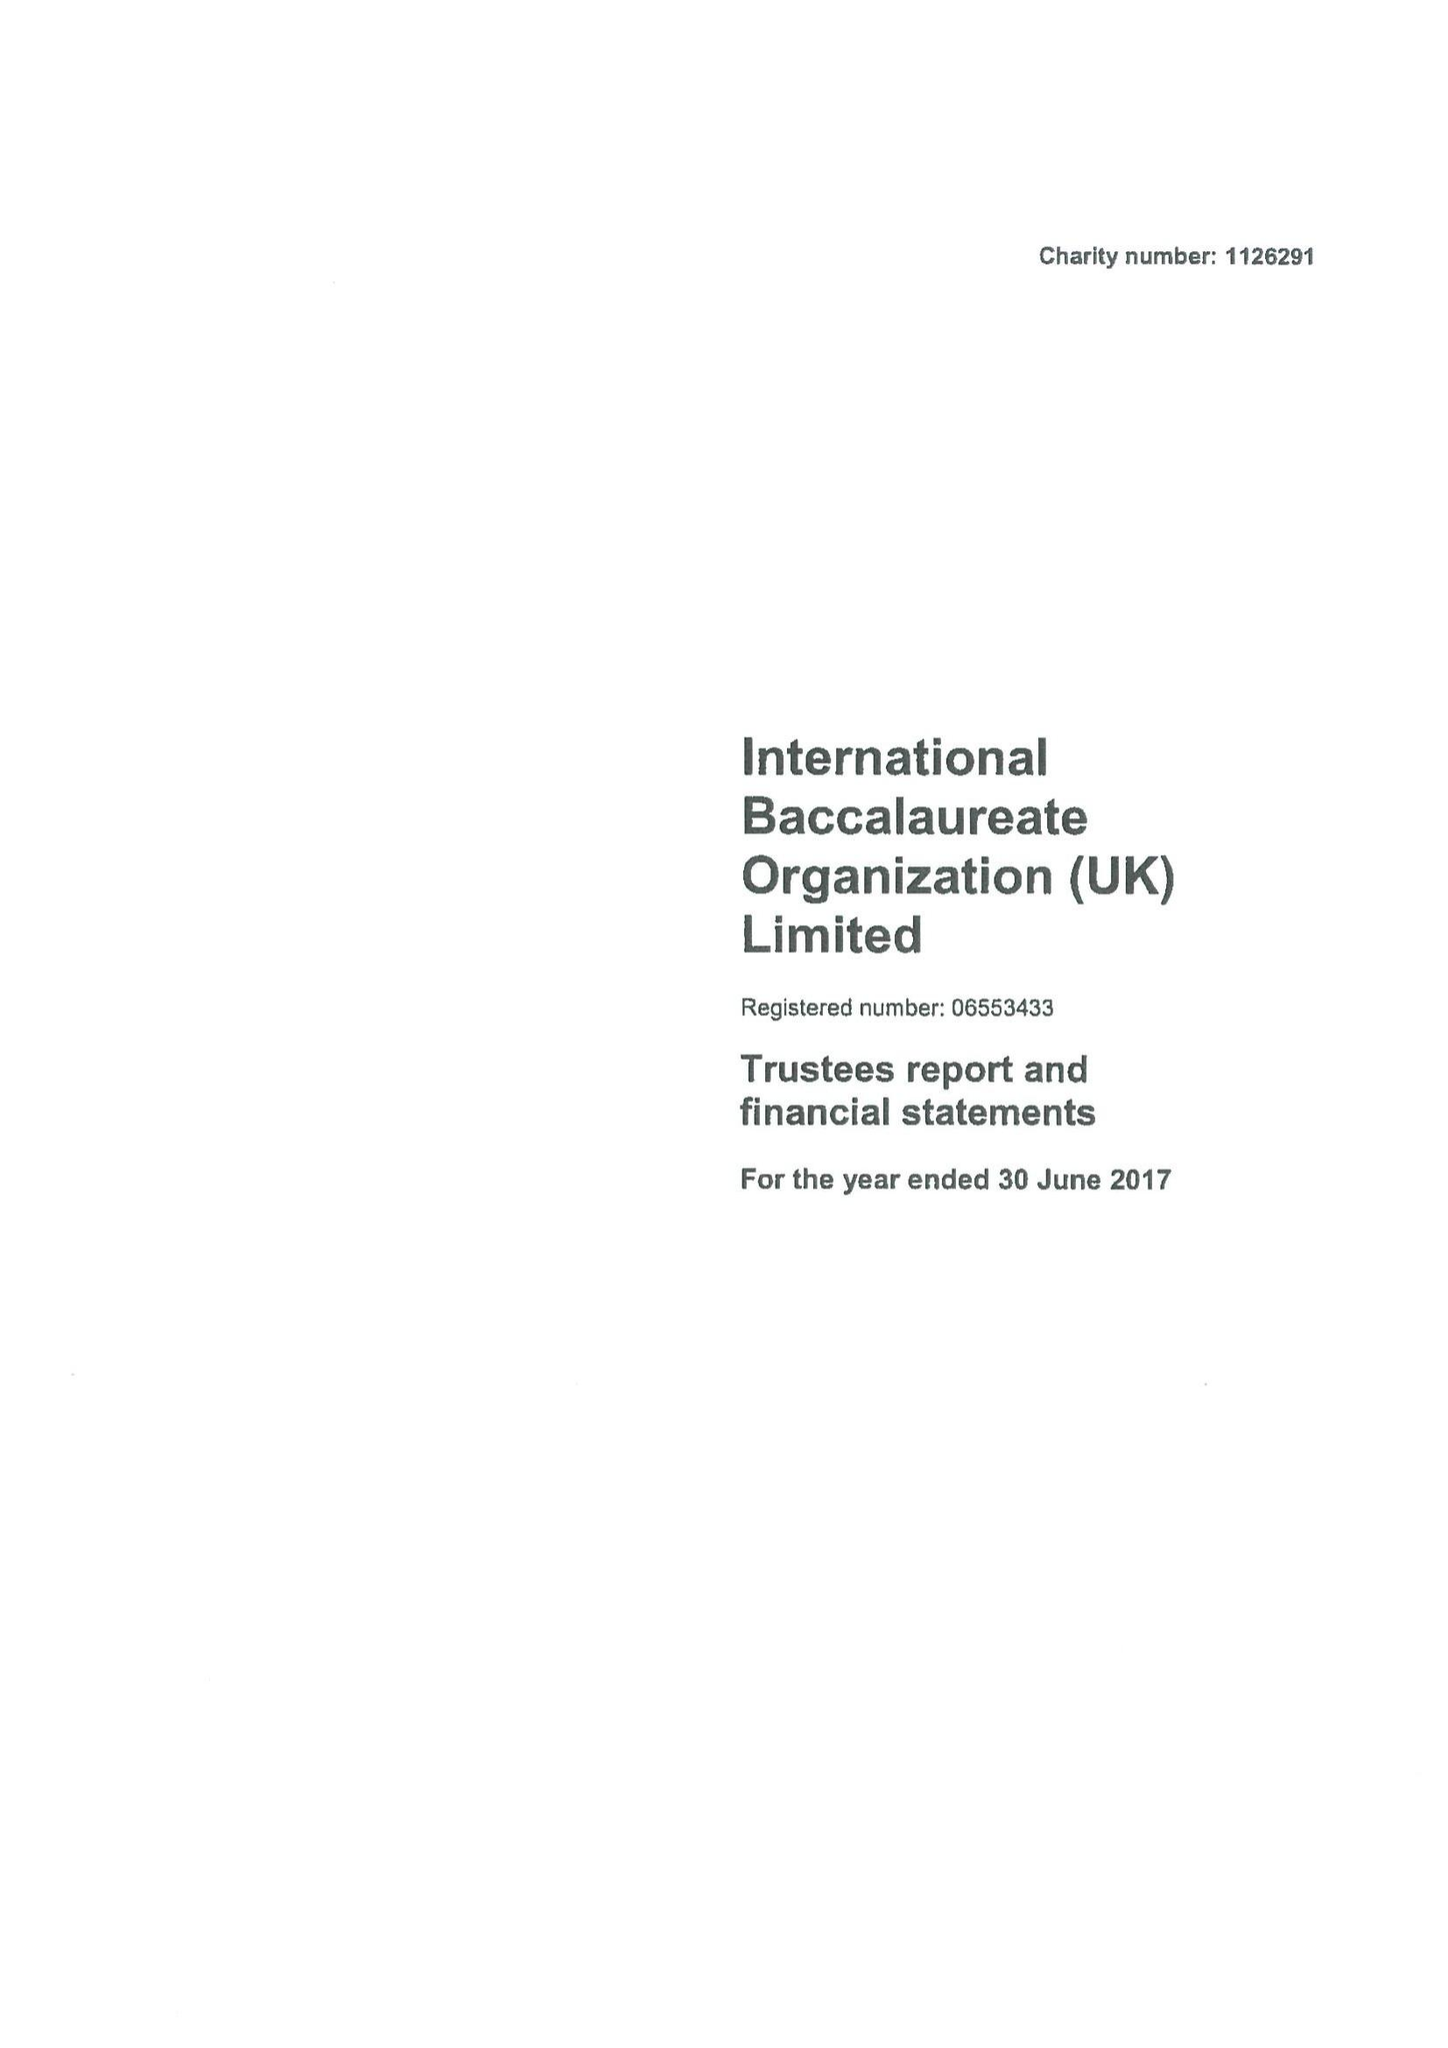What is the value for the charity_number?
Answer the question using a single word or phrase. 1126291 